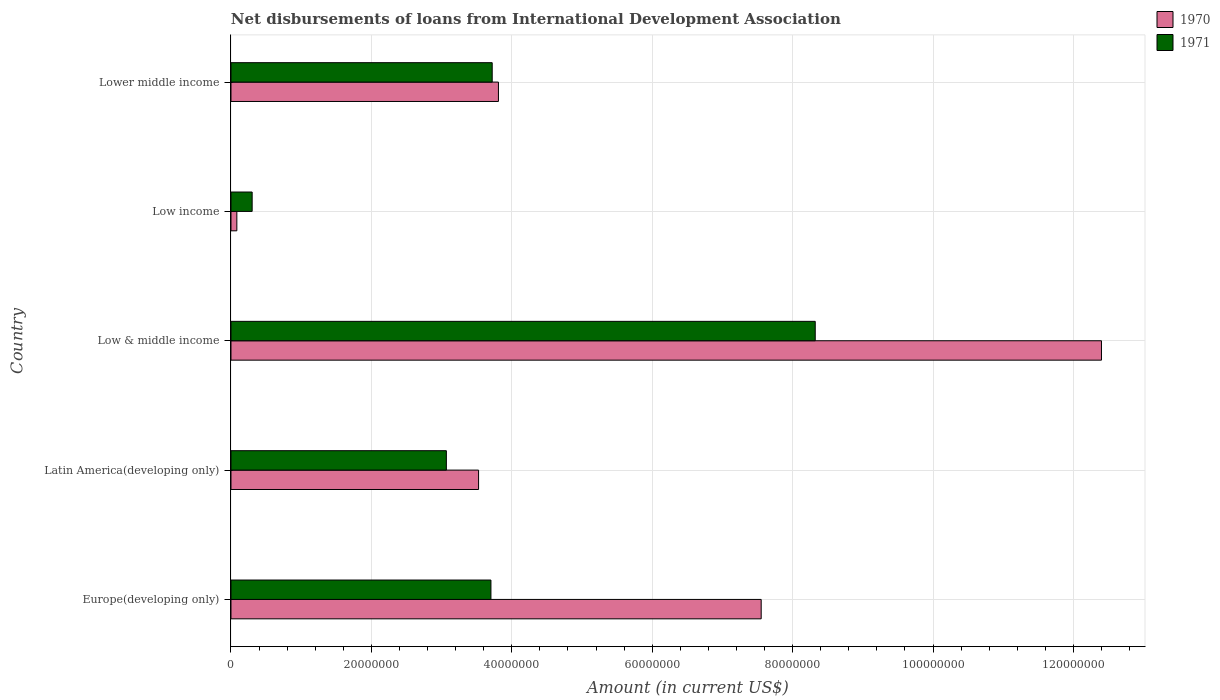How many groups of bars are there?
Your answer should be very brief. 5. Are the number of bars per tick equal to the number of legend labels?
Offer a very short reply. Yes. How many bars are there on the 2nd tick from the top?
Keep it short and to the point. 2. How many bars are there on the 5th tick from the bottom?
Provide a succinct answer. 2. What is the label of the 4th group of bars from the top?
Ensure brevity in your answer.  Latin America(developing only). In how many cases, is the number of bars for a given country not equal to the number of legend labels?
Your answer should be very brief. 0. What is the amount of loans disbursed in 1970 in Low income?
Make the answer very short. 8.35e+05. Across all countries, what is the maximum amount of loans disbursed in 1971?
Your response must be concise. 8.32e+07. Across all countries, what is the minimum amount of loans disbursed in 1971?
Your response must be concise. 3.02e+06. What is the total amount of loans disbursed in 1970 in the graph?
Give a very brief answer. 2.74e+08. What is the difference between the amount of loans disbursed in 1970 in Europe(developing only) and that in Low & middle income?
Your answer should be compact. -4.85e+07. What is the difference between the amount of loans disbursed in 1970 in Europe(developing only) and the amount of loans disbursed in 1971 in Low income?
Ensure brevity in your answer.  7.25e+07. What is the average amount of loans disbursed in 1970 per country?
Ensure brevity in your answer.  5.47e+07. What is the difference between the amount of loans disbursed in 1970 and amount of loans disbursed in 1971 in Low & middle income?
Make the answer very short. 4.08e+07. In how many countries, is the amount of loans disbursed in 1971 greater than 124000000 US$?
Your response must be concise. 0. What is the ratio of the amount of loans disbursed in 1971 in Europe(developing only) to that in Latin America(developing only)?
Your answer should be very brief. 1.21. Is the difference between the amount of loans disbursed in 1970 in Europe(developing only) and Latin America(developing only) greater than the difference between the amount of loans disbursed in 1971 in Europe(developing only) and Latin America(developing only)?
Provide a short and direct response. Yes. What is the difference between the highest and the second highest amount of loans disbursed in 1971?
Ensure brevity in your answer.  4.60e+07. What is the difference between the highest and the lowest amount of loans disbursed in 1971?
Offer a very short reply. 8.02e+07. In how many countries, is the amount of loans disbursed in 1971 greater than the average amount of loans disbursed in 1971 taken over all countries?
Offer a very short reply. 1. What does the 2nd bar from the top in Low & middle income represents?
Your answer should be very brief. 1970. What does the 1st bar from the bottom in Low & middle income represents?
Your response must be concise. 1970. How many bars are there?
Your answer should be very brief. 10. How many countries are there in the graph?
Provide a succinct answer. 5. Are the values on the major ticks of X-axis written in scientific E-notation?
Your answer should be very brief. No. Does the graph contain any zero values?
Keep it short and to the point. No. How many legend labels are there?
Offer a very short reply. 2. What is the title of the graph?
Offer a very short reply. Net disbursements of loans from International Development Association. What is the Amount (in current US$) of 1970 in Europe(developing only)?
Ensure brevity in your answer.  7.55e+07. What is the Amount (in current US$) in 1971 in Europe(developing only)?
Ensure brevity in your answer.  3.70e+07. What is the Amount (in current US$) in 1970 in Latin America(developing only)?
Keep it short and to the point. 3.53e+07. What is the Amount (in current US$) of 1971 in Latin America(developing only)?
Provide a short and direct response. 3.07e+07. What is the Amount (in current US$) of 1970 in Low & middle income?
Provide a succinct answer. 1.24e+08. What is the Amount (in current US$) in 1971 in Low & middle income?
Your response must be concise. 8.32e+07. What is the Amount (in current US$) in 1970 in Low income?
Your answer should be very brief. 8.35e+05. What is the Amount (in current US$) of 1971 in Low income?
Make the answer very short. 3.02e+06. What is the Amount (in current US$) of 1970 in Lower middle income?
Your answer should be very brief. 3.81e+07. What is the Amount (in current US$) in 1971 in Lower middle income?
Keep it short and to the point. 3.72e+07. Across all countries, what is the maximum Amount (in current US$) in 1970?
Make the answer very short. 1.24e+08. Across all countries, what is the maximum Amount (in current US$) in 1971?
Give a very brief answer. 8.32e+07. Across all countries, what is the minimum Amount (in current US$) in 1970?
Keep it short and to the point. 8.35e+05. Across all countries, what is the minimum Amount (in current US$) in 1971?
Your response must be concise. 3.02e+06. What is the total Amount (in current US$) in 1970 in the graph?
Your answer should be compact. 2.74e+08. What is the total Amount (in current US$) of 1971 in the graph?
Offer a very short reply. 1.91e+08. What is the difference between the Amount (in current US$) in 1970 in Europe(developing only) and that in Latin America(developing only)?
Provide a succinct answer. 4.03e+07. What is the difference between the Amount (in current US$) of 1971 in Europe(developing only) and that in Latin America(developing only)?
Make the answer very short. 6.35e+06. What is the difference between the Amount (in current US$) in 1970 in Europe(developing only) and that in Low & middle income?
Your answer should be compact. -4.85e+07. What is the difference between the Amount (in current US$) in 1971 in Europe(developing only) and that in Low & middle income?
Make the answer very short. -4.62e+07. What is the difference between the Amount (in current US$) in 1970 in Europe(developing only) and that in Low income?
Provide a succinct answer. 7.47e+07. What is the difference between the Amount (in current US$) in 1971 in Europe(developing only) and that in Low income?
Provide a succinct answer. 3.40e+07. What is the difference between the Amount (in current US$) of 1970 in Europe(developing only) and that in Lower middle income?
Keep it short and to the point. 3.74e+07. What is the difference between the Amount (in current US$) of 1971 in Europe(developing only) and that in Lower middle income?
Provide a short and direct response. -1.81e+05. What is the difference between the Amount (in current US$) of 1970 in Latin America(developing only) and that in Low & middle income?
Your response must be concise. -8.87e+07. What is the difference between the Amount (in current US$) in 1971 in Latin America(developing only) and that in Low & middle income?
Give a very brief answer. -5.25e+07. What is the difference between the Amount (in current US$) in 1970 in Latin America(developing only) and that in Low income?
Your response must be concise. 3.44e+07. What is the difference between the Amount (in current US$) of 1971 in Latin America(developing only) and that in Low income?
Your answer should be very brief. 2.77e+07. What is the difference between the Amount (in current US$) in 1970 in Latin America(developing only) and that in Lower middle income?
Provide a short and direct response. -2.83e+06. What is the difference between the Amount (in current US$) in 1971 in Latin America(developing only) and that in Lower middle income?
Your answer should be very brief. -6.53e+06. What is the difference between the Amount (in current US$) of 1970 in Low & middle income and that in Low income?
Provide a succinct answer. 1.23e+08. What is the difference between the Amount (in current US$) of 1971 in Low & middle income and that in Low income?
Offer a very short reply. 8.02e+07. What is the difference between the Amount (in current US$) in 1970 in Low & middle income and that in Lower middle income?
Offer a very short reply. 8.59e+07. What is the difference between the Amount (in current US$) of 1971 in Low & middle income and that in Lower middle income?
Your response must be concise. 4.60e+07. What is the difference between the Amount (in current US$) of 1970 in Low income and that in Lower middle income?
Provide a succinct answer. -3.73e+07. What is the difference between the Amount (in current US$) in 1971 in Low income and that in Lower middle income?
Provide a succinct answer. -3.42e+07. What is the difference between the Amount (in current US$) of 1970 in Europe(developing only) and the Amount (in current US$) of 1971 in Latin America(developing only)?
Make the answer very short. 4.48e+07. What is the difference between the Amount (in current US$) in 1970 in Europe(developing only) and the Amount (in current US$) in 1971 in Low & middle income?
Provide a short and direct response. -7.70e+06. What is the difference between the Amount (in current US$) in 1970 in Europe(developing only) and the Amount (in current US$) in 1971 in Low income?
Offer a terse response. 7.25e+07. What is the difference between the Amount (in current US$) of 1970 in Europe(developing only) and the Amount (in current US$) of 1971 in Lower middle income?
Ensure brevity in your answer.  3.83e+07. What is the difference between the Amount (in current US$) of 1970 in Latin America(developing only) and the Amount (in current US$) of 1971 in Low & middle income?
Make the answer very short. -4.80e+07. What is the difference between the Amount (in current US$) in 1970 in Latin America(developing only) and the Amount (in current US$) in 1971 in Low income?
Your response must be concise. 3.23e+07. What is the difference between the Amount (in current US$) in 1970 in Latin America(developing only) and the Amount (in current US$) in 1971 in Lower middle income?
Your answer should be very brief. -1.94e+06. What is the difference between the Amount (in current US$) in 1970 in Low & middle income and the Amount (in current US$) in 1971 in Low income?
Give a very brief answer. 1.21e+08. What is the difference between the Amount (in current US$) in 1970 in Low & middle income and the Amount (in current US$) in 1971 in Lower middle income?
Give a very brief answer. 8.68e+07. What is the difference between the Amount (in current US$) of 1970 in Low income and the Amount (in current US$) of 1971 in Lower middle income?
Your response must be concise. -3.64e+07. What is the average Amount (in current US$) in 1970 per country?
Keep it short and to the point. 5.47e+07. What is the average Amount (in current US$) in 1971 per country?
Give a very brief answer. 3.82e+07. What is the difference between the Amount (in current US$) of 1970 and Amount (in current US$) of 1971 in Europe(developing only)?
Your answer should be compact. 3.85e+07. What is the difference between the Amount (in current US$) in 1970 and Amount (in current US$) in 1971 in Latin America(developing only)?
Ensure brevity in your answer.  4.59e+06. What is the difference between the Amount (in current US$) in 1970 and Amount (in current US$) in 1971 in Low & middle income?
Provide a succinct answer. 4.08e+07. What is the difference between the Amount (in current US$) in 1970 and Amount (in current US$) in 1971 in Low income?
Give a very brief answer. -2.18e+06. What is the difference between the Amount (in current US$) in 1970 and Amount (in current US$) in 1971 in Lower middle income?
Give a very brief answer. 8.88e+05. What is the ratio of the Amount (in current US$) of 1970 in Europe(developing only) to that in Latin America(developing only)?
Keep it short and to the point. 2.14. What is the ratio of the Amount (in current US$) in 1971 in Europe(developing only) to that in Latin America(developing only)?
Make the answer very short. 1.21. What is the ratio of the Amount (in current US$) of 1970 in Europe(developing only) to that in Low & middle income?
Provide a short and direct response. 0.61. What is the ratio of the Amount (in current US$) of 1971 in Europe(developing only) to that in Low & middle income?
Ensure brevity in your answer.  0.44. What is the ratio of the Amount (in current US$) in 1970 in Europe(developing only) to that in Low income?
Provide a succinct answer. 90.45. What is the ratio of the Amount (in current US$) in 1971 in Europe(developing only) to that in Low income?
Provide a short and direct response. 12.28. What is the ratio of the Amount (in current US$) in 1970 in Europe(developing only) to that in Lower middle income?
Your answer should be compact. 1.98. What is the ratio of the Amount (in current US$) in 1971 in Europe(developing only) to that in Lower middle income?
Your response must be concise. 1. What is the ratio of the Amount (in current US$) of 1970 in Latin America(developing only) to that in Low & middle income?
Keep it short and to the point. 0.28. What is the ratio of the Amount (in current US$) of 1971 in Latin America(developing only) to that in Low & middle income?
Your answer should be compact. 0.37. What is the ratio of the Amount (in current US$) in 1970 in Latin America(developing only) to that in Low income?
Provide a succinct answer. 42.24. What is the ratio of the Amount (in current US$) in 1971 in Latin America(developing only) to that in Low income?
Your answer should be compact. 10.17. What is the ratio of the Amount (in current US$) of 1970 in Latin America(developing only) to that in Lower middle income?
Offer a terse response. 0.93. What is the ratio of the Amount (in current US$) in 1971 in Latin America(developing only) to that in Lower middle income?
Your response must be concise. 0.82. What is the ratio of the Amount (in current US$) in 1970 in Low & middle income to that in Low income?
Ensure brevity in your answer.  148.5. What is the ratio of the Amount (in current US$) of 1971 in Low & middle income to that in Low income?
Give a very brief answer. 27.59. What is the ratio of the Amount (in current US$) of 1970 in Low & middle income to that in Lower middle income?
Keep it short and to the point. 3.25. What is the ratio of the Amount (in current US$) in 1971 in Low & middle income to that in Lower middle income?
Provide a succinct answer. 2.24. What is the ratio of the Amount (in current US$) of 1970 in Low income to that in Lower middle income?
Your answer should be very brief. 0.02. What is the ratio of the Amount (in current US$) in 1971 in Low income to that in Lower middle income?
Offer a terse response. 0.08. What is the difference between the highest and the second highest Amount (in current US$) of 1970?
Make the answer very short. 4.85e+07. What is the difference between the highest and the second highest Amount (in current US$) of 1971?
Offer a terse response. 4.60e+07. What is the difference between the highest and the lowest Amount (in current US$) of 1970?
Ensure brevity in your answer.  1.23e+08. What is the difference between the highest and the lowest Amount (in current US$) in 1971?
Your answer should be very brief. 8.02e+07. 